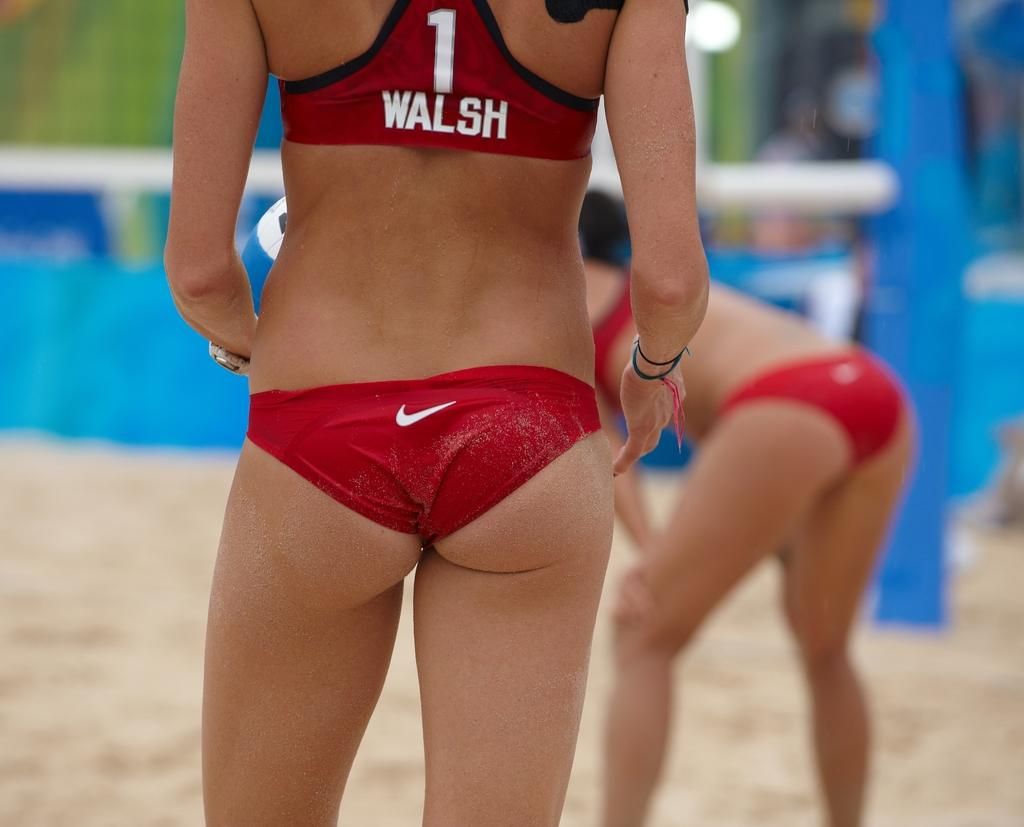Provide a one-sentence caption for the provided image. Sportswoman Walsh stands on sand wearing red clothing. 